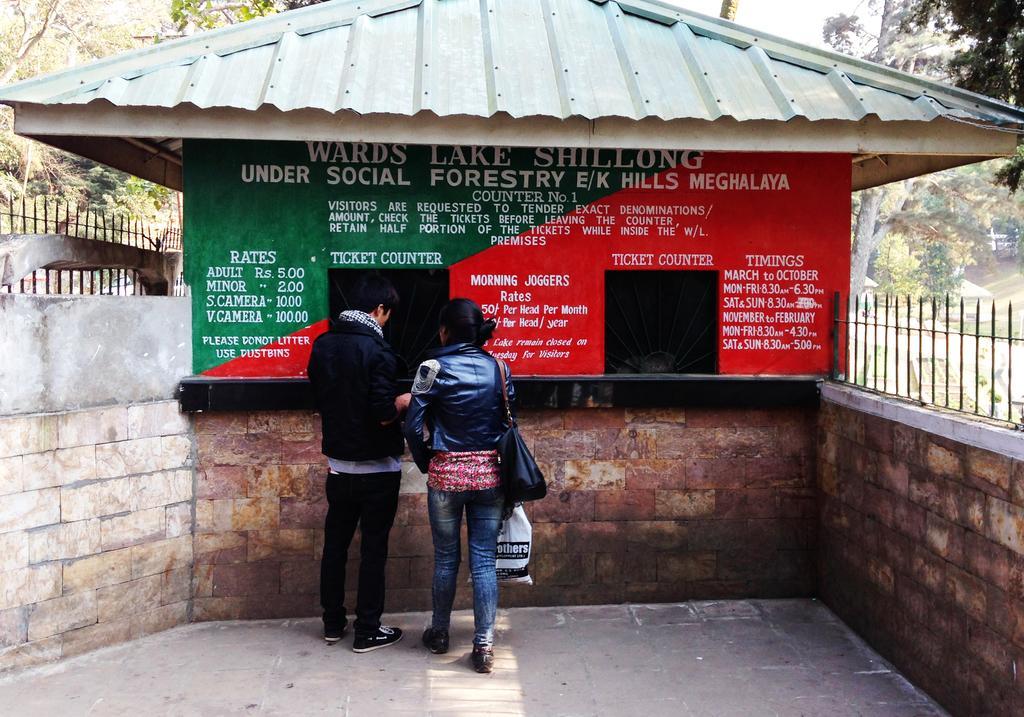Can you describe this image briefly? In this image I can see two persons wearing black jackets are standing on the ground. In the background I can see the building, two walls, the railing, few trees and the sky. 